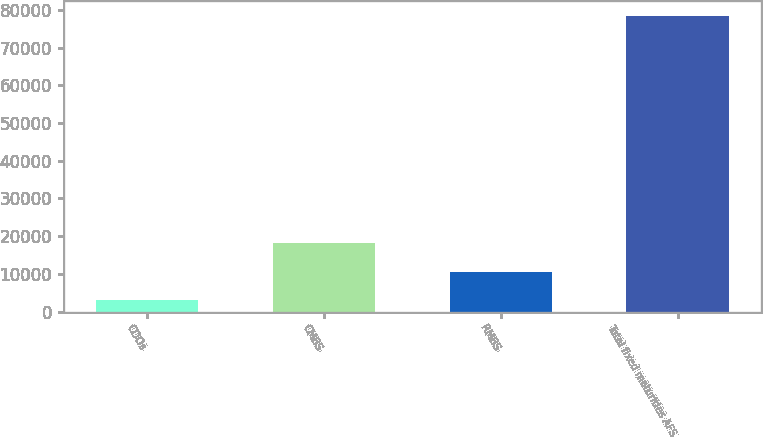Convert chart to OTSL. <chart><loc_0><loc_0><loc_500><loc_500><bar_chart><fcel>CDOs<fcel>CMBS<fcel>RMBS<fcel>Total fixed maturities AFS<nl><fcel>3088<fcel>18154.2<fcel>10621.1<fcel>78419<nl></chart> 